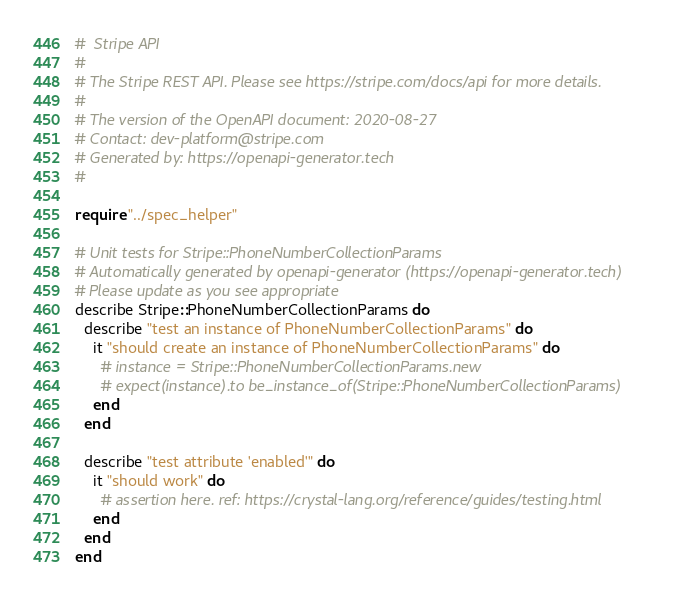Convert code to text. <code><loc_0><loc_0><loc_500><loc_500><_Crystal_>#  Stripe API
#
# The Stripe REST API. Please see https://stripe.com/docs/api for more details.
#
# The version of the OpenAPI document: 2020-08-27
# Contact: dev-platform@stripe.com
# Generated by: https://openapi-generator.tech
#

require "../spec_helper"

# Unit tests for Stripe::PhoneNumberCollectionParams
# Automatically generated by openapi-generator (https://openapi-generator.tech)
# Please update as you see appropriate
describe Stripe::PhoneNumberCollectionParams do
  describe "test an instance of PhoneNumberCollectionParams" do
    it "should create an instance of PhoneNumberCollectionParams" do
      # instance = Stripe::PhoneNumberCollectionParams.new
      # expect(instance).to be_instance_of(Stripe::PhoneNumberCollectionParams)
    end
  end

  describe "test attribute 'enabled'" do
    it "should work" do
      # assertion here. ref: https://crystal-lang.org/reference/guides/testing.html
    end
  end
end
</code> 